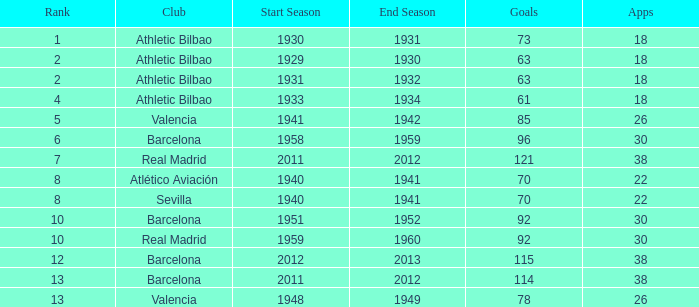How many apps when the rank was after 13 and having more than 73 goals? None. 